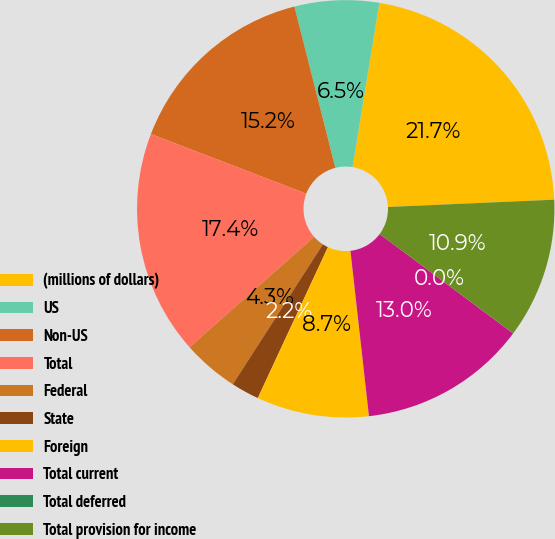Convert chart to OTSL. <chart><loc_0><loc_0><loc_500><loc_500><pie_chart><fcel>(millions of dollars)<fcel>US<fcel>Non-US<fcel>Total<fcel>Federal<fcel>State<fcel>Foreign<fcel>Total current<fcel>Total deferred<fcel>Total provision for income<nl><fcel>21.73%<fcel>6.53%<fcel>15.21%<fcel>17.38%<fcel>4.35%<fcel>2.18%<fcel>8.7%<fcel>13.04%<fcel>0.01%<fcel>10.87%<nl></chart> 